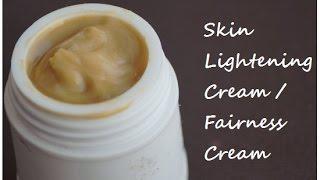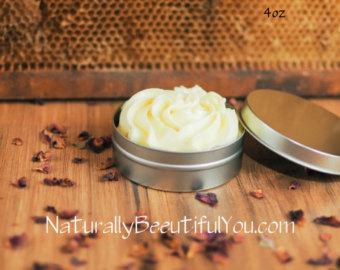The first image is the image on the left, the second image is the image on the right. For the images shown, is this caption "A silver lid is resting against a container in the image on the right." true? Answer yes or no. Yes. The first image is the image on the left, the second image is the image on the right. Analyze the images presented: Is the assertion "Each image shows one open jar filled with a creamy substance, and in one image, a silver lid is leaning at any angle against the edge of the jar." valid? Answer yes or no. Yes. 